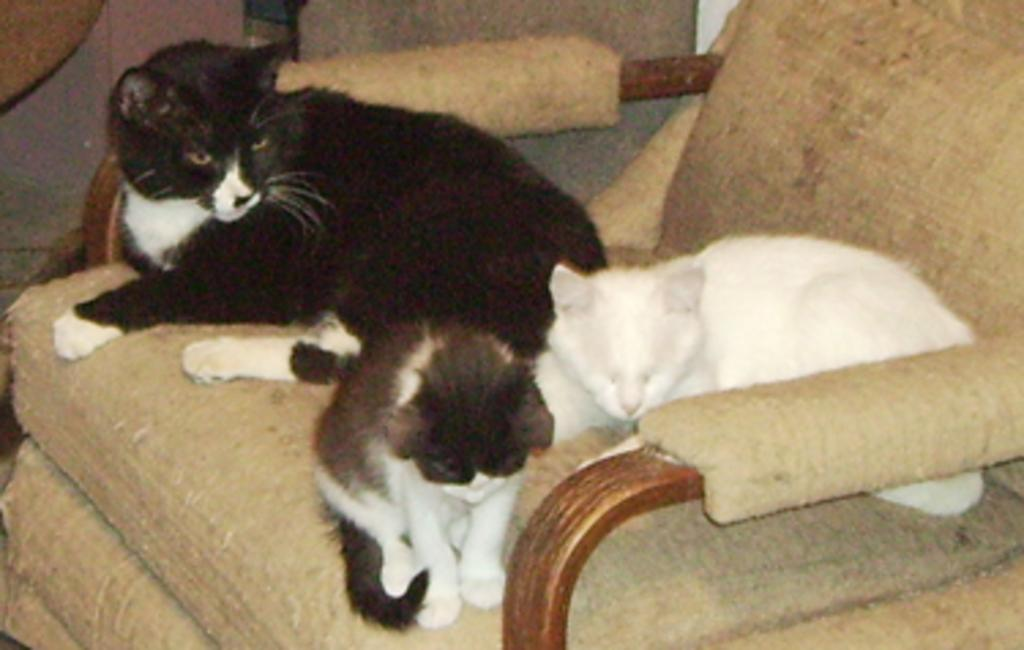What type of furniture is present in the image? There is a sofa in the image. What kind of animal can be seen on the sofa? There is a white color cat on the sofa. How many black color cats are on the sofa? There are two black color cats on the sofa. What type of list is visible on the sofa? There is no list present on the sofa; it features a white color cat and two black color cats. 